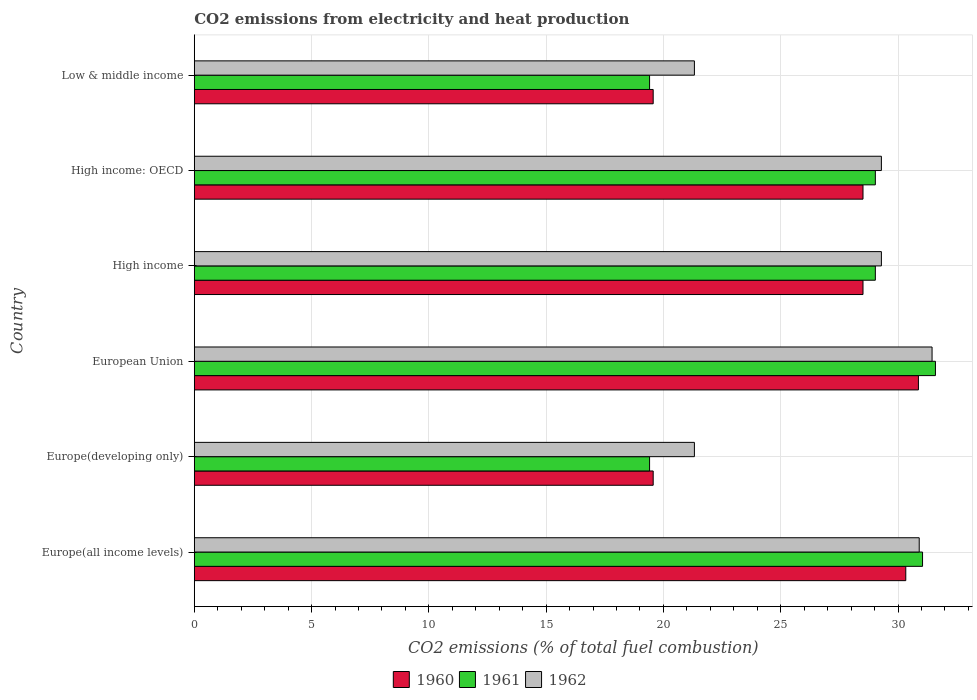How many different coloured bars are there?
Keep it short and to the point. 3. Are the number of bars per tick equal to the number of legend labels?
Make the answer very short. Yes. How many bars are there on the 3rd tick from the top?
Your answer should be compact. 3. How many bars are there on the 1st tick from the bottom?
Your answer should be very brief. 3. What is the label of the 2nd group of bars from the top?
Your answer should be very brief. High income: OECD. What is the amount of CO2 emitted in 1962 in High income?
Make the answer very short. 29.29. Across all countries, what is the maximum amount of CO2 emitted in 1961?
Provide a short and direct response. 31.59. Across all countries, what is the minimum amount of CO2 emitted in 1961?
Offer a very short reply. 19.41. In which country was the amount of CO2 emitted in 1961 minimum?
Your answer should be compact. Europe(developing only). What is the total amount of CO2 emitted in 1960 in the graph?
Provide a succinct answer. 157.34. What is the difference between the amount of CO2 emitted in 1962 in European Union and that in Low & middle income?
Your response must be concise. 10.13. What is the difference between the amount of CO2 emitted in 1960 in High income: OECD and the amount of CO2 emitted in 1961 in Europe(all income levels)?
Your answer should be very brief. -2.54. What is the average amount of CO2 emitted in 1962 per country?
Provide a short and direct response. 27.26. What is the difference between the amount of CO2 emitted in 1962 and amount of CO2 emitted in 1960 in High income: OECD?
Ensure brevity in your answer.  0.78. In how many countries, is the amount of CO2 emitted in 1960 greater than 12 %?
Your answer should be very brief. 6. What is the ratio of the amount of CO2 emitted in 1961 in Europe(developing only) to that in High income?
Offer a terse response. 0.67. Is the amount of CO2 emitted in 1962 in High income less than that in Low & middle income?
Offer a very short reply. No. Is the difference between the amount of CO2 emitted in 1962 in European Union and High income greater than the difference between the amount of CO2 emitted in 1960 in European Union and High income?
Provide a short and direct response. No. What is the difference between the highest and the second highest amount of CO2 emitted in 1960?
Give a very brief answer. 0.54. What is the difference between the highest and the lowest amount of CO2 emitted in 1960?
Offer a very short reply. 11.31. Is the sum of the amount of CO2 emitted in 1962 in Europe(all income levels) and European Union greater than the maximum amount of CO2 emitted in 1960 across all countries?
Provide a succinct answer. Yes. What does the 2nd bar from the top in High income: OECD represents?
Offer a very short reply. 1961. What does the 3rd bar from the bottom in High income: OECD represents?
Your answer should be compact. 1962. Is it the case that in every country, the sum of the amount of CO2 emitted in 1961 and amount of CO2 emitted in 1960 is greater than the amount of CO2 emitted in 1962?
Give a very brief answer. Yes. How many bars are there?
Offer a very short reply. 18. How many countries are there in the graph?
Your response must be concise. 6. What is the difference between two consecutive major ticks on the X-axis?
Make the answer very short. 5. Are the values on the major ticks of X-axis written in scientific E-notation?
Give a very brief answer. No. Does the graph contain grids?
Offer a terse response. Yes. How many legend labels are there?
Your answer should be compact. 3. How are the legend labels stacked?
Your response must be concise. Horizontal. What is the title of the graph?
Give a very brief answer. CO2 emissions from electricity and heat production. What is the label or title of the X-axis?
Your answer should be very brief. CO2 emissions (% of total fuel combustion). What is the label or title of the Y-axis?
Offer a terse response. Country. What is the CO2 emissions (% of total fuel combustion) in 1960 in Europe(all income levels)?
Offer a terse response. 30.33. What is the CO2 emissions (% of total fuel combustion) in 1961 in Europe(all income levels)?
Provide a short and direct response. 31.04. What is the CO2 emissions (% of total fuel combustion) of 1962 in Europe(all income levels)?
Your answer should be very brief. 30.9. What is the CO2 emissions (% of total fuel combustion) in 1960 in Europe(developing only)?
Make the answer very short. 19.56. What is the CO2 emissions (% of total fuel combustion) in 1961 in Europe(developing only)?
Offer a very short reply. 19.41. What is the CO2 emissions (% of total fuel combustion) of 1962 in Europe(developing only)?
Provide a succinct answer. 21.32. What is the CO2 emissions (% of total fuel combustion) in 1960 in European Union?
Give a very brief answer. 30.87. What is the CO2 emissions (% of total fuel combustion) in 1961 in European Union?
Provide a succinct answer. 31.59. What is the CO2 emissions (% of total fuel combustion) in 1962 in European Union?
Your response must be concise. 31.45. What is the CO2 emissions (% of total fuel combustion) in 1960 in High income?
Ensure brevity in your answer.  28.51. What is the CO2 emissions (% of total fuel combustion) of 1961 in High income?
Provide a succinct answer. 29.03. What is the CO2 emissions (% of total fuel combustion) of 1962 in High income?
Your answer should be compact. 29.29. What is the CO2 emissions (% of total fuel combustion) in 1960 in High income: OECD?
Offer a terse response. 28.51. What is the CO2 emissions (% of total fuel combustion) in 1961 in High income: OECD?
Give a very brief answer. 29.03. What is the CO2 emissions (% of total fuel combustion) in 1962 in High income: OECD?
Your answer should be very brief. 29.29. What is the CO2 emissions (% of total fuel combustion) in 1960 in Low & middle income?
Offer a terse response. 19.56. What is the CO2 emissions (% of total fuel combustion) in 1961 in Low & middle income?
Offer a terse response. 19.41. What is the CO2 emissions (% of total fuel combustion) in 1962 in Low & middle income?
Keep it short and to the point. 21.32. Across all countries, what is the maximum CO2 emissions (% of total fuel combustion) in 1960?
Provide a short and direct response. 30.87. Across all countries, what is the maximum CO2 emissions (% of total fuel combustion) of 1961?
Give a very brief answer. 31.59. Across all countries, what is the maximum CO2 emissions (% of total fuel combustion) in 1962?
Provide a succinct answer. 31.45. Across all countries, what is the minimum CO2 emissions (% of total fuel combustion) of 1960?
Ensure brevity in your answer.  19.56. Across all countries, what is the minimum CO2 emissions (% of total fuel combustion) in 1961?
Your answer should be very brief. 19.41. Across all countries, what is the minimum CO2 emissions (% of total fuel combustion) in 1962?
Provide a succinct answer. 21.32. What is the total CO2 emissions (% of total fuel combustion) of 1960 in the graph?
Make the answer very short. 157.34. What is the total CO2 emissions (% of total fuel combustion) of 1961 in the graph?
Offer a terse response. 159.52. What is the total CO2 emissions (% of total fuel combustion) in 1962 in the graph?
Give a very brief answer. 163.57. What is the difference between the CO2 emissions (% of total fuel combustion) of 1960 in Europe(all income levels) and that in Europe(developing only)?
Offer a terse response. 10.77. What is the difference between the CO2 emissions (% of total fuel combustion) in 1961 in Europe(all income levels) and that in Europe(developing only)?
Provide a succinct answer. 11.64. What is the difference between the CO2 emissions (% of total fuel combustion) of 1962 in Europe(all income levels) and that in Europe(developing only)?
Make the answer very short. 9.58. What is the difference between the CO2 emissions (% of total fuel combustion) in 1960 in Europe(all income levels) and that in European Union?
Keep it short and to the point. -0.54. What is the difference between the CO2 emissions (% of total fuel combustion) in 1961 in Europe(all income levels) and that in European Union?
Your response must be concise. -0.55. What is the difference between the CO2 emissions (% of total fuel combustion) of 1962 in Europe(all income levels) and that in European Union?
Offer a terse response. -0.55. What is the difference between the CO2 emissions (% of total fuel combustion) in 1960 in Europe(all income levels) and that in High income?
Ensure brevity in your answer.  1.82. What is the difference between the CO2 emissions (% of total fuel combustion) of 1961 in Europe(all income levels) and that in High income?
Provide a succinct answer. 2.01. What is the difference between the CO2 emissions (% of total fuel combustion) of 1962 in Europe(all income levels) and that in High income?
Give a very brief answer. 1.61. What is the difference between the CO2 emissions (% of total fuel combustion) in 1960 in Europe(all income levels) and that in High income: OECD?
Provide a short and direct response. 1.82. What is the difference between the CO2 emissions (% of total fuel combustion) in 1961 in Europe(all income levels) and that in High income: OECD?
Make the answer very short. 2.01. What is the difference between the CO2 emissions (% of total fuel combustion) of 1962 in Europe(all income levels) and that in High income: OECD?
Offer a terse response. 1.61. What is the difference between the CO2 emissions (% of total fuel combustion) in 1960 in Europe(all income levels) and that in Low & middle income?
Your answer should be very brief. 10.77. What is the difference between the CO2 emissions (% of total fuel combustion) of 1961 in Europe(all income levels) and that in Low & middle income?
Keep it short and to the point. 11.64. What is the difference between the CO2 emissions (% of total fuel combustion) in 1962 in Europe(all income levels) and that in Low & middle income?
Make the answer very short. 9.58. What is the difference between the CO2 emissions (% of total fuel combustion) in 1960 in Europe(developing only) and that in European Union?
Give a very brief answer. -11.31. What is the difference between the CO2 emissions (% of total fuel combustion) in 1961 in Europe(developing only) and that in European Union?
Give a very brief answer. -12.19. What is the difference between the CO2 emissions (% of total fuel combustion) of 1962 in Europe(developing only) and that in European Union?
Your answer should be compact. -10.13. What is the difference between the CO2 emissions (% of total fuel combustion) in 1960 in Europe(developing only) and that in High income?
Keep it short and to the point. -8.94. What is the difference between the CO2 emissions (% of total fuel combustion) of 1961 in Europe(developing only) and that in High income?
Provide a succinct answer. -9.62. What is the difference between the CO2 emissions (% of total fuel combustion) of 1962 in Europe(developing only) and that in High income?
Give a very brief answer. -7.97. What is the difference between the CO2 emissions (% of total fuel combustion) in 1960 in Europe(developing only) and that in High income: OECD?
Your answer should be compact. -8.94. What is the difference between the CO2 emissions (% of total fuel combustion) of 1961 in Europe(developing only) and that in High income: OECD?
Provide a succinct answer. -9.62. What is the difference between the CO2 emissions (% of total fuel combustion) of 1962 in Europe(developing only) and that in High income: OECD?
Keep it short and to the point. -7.97. What is the difference between the CO2 emissions (% of total fuel combustion) in 1960 in Europe(developing only) and that in Low & middle income?
Ensure brevity in your answer.  0. What is the difference between the CO2 emissions (% of total fuel combustion) of 1961 in Europe(developing only) and that in Low & middle income?
Give a very brief answer. 0. What is the difference between the CO2 emissions (% of total fuel combustion) in 1962 in Europe(developing only) and that in Low & middle income?
Provide a succinct answer. 0. What is the difference between the CO2 emissions (% of total fuel combustion) of 1960 in European Union and that in High income?
Keep it short and to the point. 2.36. What is the difference between the CO2 emissions (% of total fuel combustion) in 1961 in European Union and that in High income?
Provide a succinct answer. 2.56. What is the difference between the CO2 emissions (% of total fuel combustion) in 1962 in European Union and that in High income?
Make the answer very short. 2.16. What is the difference between the CO2 emissions (% of total fuel combustion) of 1960 in European Union and that in High income: OECD?
Your answer should be compact. 2.36. What is the difference between the CO2 emissions (% of total fuel combustion) in 1961 in European Union and that in High income: OECD?
Offer a terse response. 2.56. What is the difference between the CO2 emissions (% of total fuel combustion) in 1962 in European Union and that in High income: OECD?
Give a very brief answer. 2.16. What is the difference between the CO2 emissions (% of total fuel combustion) in 1960 in European Union and that in Low & middle income?
Your answer should be compact. 11.31. What is the difference between the CO2 emissions (% of total fuel combustion) in 1961 in European Union and that in Low & middle income?
Give a very brief answer. 12.19. What is the difference between the CO2 emissions (% of total fuel combustion) in 1962 in European Union and that in Low & middle income?
Provide a succinct answer. 10.13. What is the difference between the CO2 emissions (% of total fuel combustion) of 1962 in High income and that in High income: OECD?
Your answer should be compact. 0. What is the difference between the CO2 emissions (% of total fuel combustion) in 1960 in High income and that in Low & middle income?
Provide a short and direct response. 8.94. What is the difference between the CO2 emissions (% of total fuel combustion) of 1961 in High income and that in Low & middle income?
Offer a very short reply. 9.62. What is the difference between the CO2 emissions (% of total fuel combustion) of 1962 in High income and that in Low & middle income?
Provide a short and direct response. 7.97. What is the difference between the CO2 emissions (% of total fuel combustion) in 1960 in High income: OECD and that in Low & middle income?
Your answer should be very brief. 8.94. What is the difference between the CO2 emissions (% of total fuel combustion) in 1961 in High income: OECD and that in Low & middle income?
Your answer should be very brief. 9.62. What is the difference between the CO2 emissions (% of total fuel combustion) of 1962 in High income: OECD and that in Low & middle income?
Provide a short and direct response. 7.97. What is the difference between the CO2 emissions (% of total fuel combustion) in 1960 in Europe(all income levels) and the CO2 emissions (% of total fuel combustion) in 1961 in Europe(developing only)?
Offer a terse response. 10.92. What is the difference between the CO2 emissions (% of total fuel combustion) in 1960 in Europe(all income levels) and the CO2 emissions (% of total fuel combustion) in 1962 in Europe(developing only)?
Offer a very short reply. 9.01. What is the difference between the CO2 emissions (% of total fuel combustion) of 1961 in Europe(all income levels) and the CO2 emissions (% of total fuel combustion) of 1962 in Europe(developing only)?
Your response must be concise. 9.73. What is the difference between the CO2 emissions (% of total fuel combustion) of 1960 in Europe(all income levels) and the CO2 emissions (% of total fuel combustion) of 1961 in European Union?
Your answer should be compact. -1.26. What is the difference between the CO2 emissions (% of total fuel combustion) of 1960 in Europe(all income levels) and the CO2 emissions (% of total fuel combustion) of 1962 in European Union?
Your answer should be very brief. -1.12. What is the difference between the CO2 emissions (% of total fuel combustion) in 1961 in Europe(all income levels) and the CO2 emissions (% of total fuel combustion) in 1962 in European Union?
Provide a short and direct response. -0.41. What is the difference between the CO2 emissions (% of total fuel combustion) of 1960 in Europe(all income levels) and the CO2 emissions (% of total fuel combustion) of 1961 in High income?
Make the answer very short. 1.3. What is the difference between the CO2 emissions (% of total fuel combustion) in 1961 in Europe(all income levels) and the CO2 emissions (% of total fuel combustion) in 1962 in High income?
Give a very brief answer. 1.75. What is the difference between the CO2 emissions (% of total fuel combustion) in 1960 in Europe(all income levels) and the CO2 emissions (% of total fuel combustion) in 1961 in High income: OECD?
Provide a succinct answer. 1.3. What is the difference between the CO2 emissions (% of total fuel combustion) in 1960 in Europe(all income levels) and the CO2 emissions (% of total fuel combustion) in 1962 in High income: OECD?
Your answer should be very brief. 1.04. What is the difference between the CO2 emissions (% of total fuel combustion) of 1961 in Europe(all income levels) and the CO2 emissions (% of total fuel combustion) of 1962 in High income: OECD?
Make the answer very short. 1.75. What is the difference between the CO2 emissions (% of total fuel combustion) in 1960 in Europe(all income levels) and the CO2 emissions (% of total fuel combustion) in 1961 in Low & middle income?
Your answer should be very brief. 10.92. What is the difference between the CO2 emissions (% of total fuel combustion) of 1960 in Europe(all income levels) and the CO2 emissions (% of total fuel combustion) of 1962 in Low & middle income?
Provide a succinct answer. 9.01. What is the difference between the CO2 emissions (% of total fuel combustion) of 1961 in Europe(all income levels) and the CO2 emissions (% of total fuel combustion) of 1962 in Low & middle income?
Your response must be concise. 9.73. What is the difference between the CO2 emissions (% of total fuel combustion) of 1960 in Europe(developing only) and the CO2 emissions (% of total fuel combustion) of 1961 in European Union?
Offer a very short reply. -12.03. What is the difference between the CO2 emissions (% of total fuel combustion) of 1960 in Europe(developing only) and the CO2 emissions (% of total fuel combustion) of 1962 in European Union?
Offer a very short reply. -11.89. What is the difference between the CO2 emissions (% of total fuel combustion) of 1961 in Europe(developing only) and the CO2 emissions (% of total fuel combustion) of 1962 in European Union?
Your answer should be very brief. -12.04. What is the difference between the CO2 emissions (% of total fuel combustion) of 1960 in Europe(developing only) and the CO2 emissions (% of total fuel combustion) of 1961 in High income?
Make the answer very short. -9.47. What is the difference between the CO2 emissions (% of total fuel combustion) of 1960 in Europe(developing only) and the CO2 emissions (% of total fuel combustion) of 1962 in High income?
Your answer should be compact. -9.73. What is the difference between the CO2 emissions (% of total fuel combustion) of 1961 in Europe(developing only) and the CO2 emissions (% of total fuel combustion) of 1962 in High income?
Your answer should be very brief. -9.88. What is the difference between the CO2 emissions (% of total fuel combustion) of 1960 in Europe(developing only) and the CO2 emissions (% of total fuel combustion) of 1961 in High income: OECD?
Give a very brief answer. -9.47. What is the difference between the CO2 emissions (% of total fuel combustion) in 1960 in Europe(developing only) and the CO2 emissions (% of total fuel combustion) in 1962 in High income: OECD?
Your answer should be compact. -9.73. What is the difference between the CO2 emissions (% of total fuel combustion) of 1961 in Europe(developing only) and the CO2 emissions (% of total fuel combustion) of 1962 in High income: OECD?
Your answer should be compact. -9.88. What is the difference between the CO2 emissions (% of total fuel combustion) of 1960 in Europe(developing only) and the CO2 emissions (% of total fuel combustion) of 1961 in Low & middle income?
Your answer should be very brief. 0.15. What is the difference between the CO2 emissions (% of total fuel combustion) of 1960 in Europe(developing only) and the CO2 emissions (% of total fuel combustion) of 1962 in Low & middle income?
Provide a short and direct response. -1.76. What is the difference between the CO2 emissions (% of total fuel combustion) in 1961 in Europe(developing only) and the CO2 emissions (% of total fuel combustion) in 1962 in Low & middle income?
Provide a short and direct response. -1.91. What is the difference between the CO2 emissions (% of total fuel combustion) in 1960 in European Union and the CO2 emissions (% of total fuel combustion) in 1961 in High income?
Provide a succinct answer. 1.84. What is the difference between the CO2 emissions (% of total fuel combustion) in 1960 in European Union and the CO2 emissions (% of total fuel combustion) in 1962 in High income?
Make the answer very short. 1.58. What is the difference between the CO2 emissions (% of total fuel combustion) of 1961 in European Union and the CO2 emissions (% of total fuel combustion) of 1962 in High income?
Ensure brevity in your answer.  2.3. What is the difference between the CO2 emissions (% of total fuel combustion) in 1960 in European Union and the CO2 emissions (% of total fuel combustion) in 1961 in High income: OECD?
Keep it short and to the point. 1.84. What is the difference between the CO2 emissions (% of total fuel combustion) of 1960 in European Union and the CO2 emissions (% of total fuel combustion) of 1962 in High income: OECD?
Ensure brevity in your answer.  1.58. What is the difference between the CO2 emissions (% of total fuel combustion) of 1961 in European Union and the CO2 emissions (% of total fuel combustion) of 1962 in High income: OECD?
Offer a very short reply. 2.3. What is the difference between the CO2 emissions (% of total fuel combustion) of 1960 in European Union and the CO2 emissions (% of total fuel combustion) of 1961 in Low & middle income?
Provide a succinct answer. 11.46. What is the difference between the CO2 emissions (% of total fuel combustion) of 1960 in European Union and the CO2 emissions (% of total fuel combustion) of 1962 in Low & middle income?
Provide a short and direct response. 9.55. What is the difference between the CO2 emissions (% of total fuel combustion) in 1961 in European Union and the CO2 emissions (% of total fuel combustion) in 1962 in Low & middle income?
Ensure brevity in your answer.  10.27. What is the difference between the CO2 emissions (% of total fuel combustion) in 1960 in High income and the CO2 emissions (% of total fuel combustion) in 1961 in High income: OECD?
Offer a terse response. -0.53. What is the difference between the CO2 emissions (% of total fuel combustion) of 1960 in High income and the CO2 emissions (% of total fuel combustion) of 1962 in High income: OECD?
Ensure brevity in your answer.  -0.78. What is the difference between the CO2 emissions (% of total fuel combustion) of 1961 in High income and the CO2 emissions (% of total fuel combustion) of 1962 in High income: OECD?
Give a very brief answer. -0.26. What is the difference between the CO2 emissions (% of total fuel combustion) of 1960 in High income and the CO2 emissions (% of total fuel combustion) of 1961 in Low & middle income?
Provide a succinct answer. 9.1. What is the difference between the CO2 emissions (% of total fuel combustion) in 1960 in High income and the CO2 emissions (% of total fuel combustion) in 1962 in Low & middle income?
Your answer should be very brief. 7.19. What is the difference between the CO2 emissions (% of total fuel combustion) of 1961 in High income and the CO2 emissions (% of total fuel combustion) of 1962 in Low & middle income?
Make the answer very short. 7.71. What is the difference between the CO2 emissions (% of total fuel combustion) in 1960 in High income: OECD and the CO2 emissions (% of total fuel combustion) in 1961 in Low & middle income?
Keep it short and to the point. 9.1. What is the difference between the CO2 emissions (% of total fuel combustion) of 1960 in High income: OECD and the CO2 emissions (% of total fuel combustion) of 1962 in Low & middle income?
Keep it short and to the point. 7.19. What is the difference between the CO2 emissions (% of total fuel combustion) in 1961 in High income: OECD and the CO2 emissions (% of total fuel combustion) in 1962 in Low & middle income?
Provide a short and direct response. 7.71. What is the average CO2 emissions (% of total fuel combustion) in 1960 per country?
Keep it short and to the point. 26.22. What is the average CO2 emissions (% of total fuel combustion) in 1961 per country?
Offer a terse response. 26.59. What is the average CO2 emissions (% of total fuel combustion) of 1962 per country?
Your response must be concise. 27.26. What is the difference between the CO2 emissions (% of total fuel combustion) of 1960 and CO2 emissions (% of total fuel combustion) of 1961 in Europe(all income levels)?
Your answer should be compact. -0.71. What is the difference between the CO2 emissions (% of total fuel combustion) in 1960 and CO2 emissions (% of total fuel combustion) in 1962 in Europe(all income levels)?
Ensure brevity in your answer.  -0.57. What is the difference between the CO2 emissions (% of total fuel combustion) of 1961 and CO2 emissions (% of total fuel combustion) of 1962 in Europe(all income levels)?
Ensure brevity in your answer.  0.14. What is the difference between the CO2 emissions (% of total fuel combustion) in 1960 and CO2 emissions (% of total fuel combustion) in 1961 in Europe(developing only)?
Your answer should be very brief. 0.15. What is the difference between the CO2 emissions (% of total fuel combustion) of 1960 and CO2 emissions (% of total fuel combustion) of 1962 in Europe(developing only)?
Offer a very short reply. -1.76. What is the difference between the CO2 emissions (% of total fuel combustion) of 1961 and CO2 emissions (% of total fuel combustion) of 1962 in Europe(developing only)?
Ensure brevity in your answer.  -1.91. What is the difference between the CO2 emissions (% of total fuel combustion) of 1960 and CO2 emissions (% of total fuel combustion) of 1961 in European Union?
Your response must be concise. -0.73. What is the difference between the CO2 emissions (% of total fuel combustion) in 1960 and CO2 emissions (% of total fuel combustion) in 1962 in European Union?
Provide a succinct answer. -0.58. What is the difference between the CO2 emissions (% of total fuel combustion) of 1961 and CO2 emissions (% of total fuel combustion) of 1962 in European Union?
Ensure brevity in your answer.  0.14. What is the difference between the CO2 emissions (% of total fuel combustion) in 1960 and CO2 emissions (% of total fuel combustion) in 1961 in High income?
Make the answer very short. -0.53. What is the difference between the CO2 emissions (% of total fuel combustion) of 1960 and CO2 emissions (% of total fuel combustion) of 1962 in High income?
Provide a short and direct response. -0.78. What is the difference between the CO2 emissions (% of total fuel combustion) in 1961 and CO2 emissions (% of total fuel combustion) in 1962 in High income?
Provide a succinct answer. -0.26. What is the difference between the CO2 emissions (% of total fuel combustion) of 1960 and CO2 emissions (% of total fuel combustion) of 1961 in High income: OECD?
Provide a short and direct response. -0.53. What is the difference between the CO2 emissions (% of total fuel combustion) of 1960 and CO2 emissions (% of total fuel combustion) of 1962 in High income: OECD?
Your answer should be very brief. -0.78. What is the difference between the CO2 emissions (% of total fuel combustion) in 1961 and CO2 emissions (% of total fuel combustion) in 1962 in High income: OECD?
Make the answer very short. -0.26. What is the difference between the CO2 emissions (% of total fuel combustion) in 1960 and CO2 emissions (% of total fuel combustion) in 1961 in Low & middle income?
Make the answer very short. 0.15. What is the difference between the CO2 emissions (% of total fuel combustion) of 1960 and CO2 emissions (% of total fuel combustion) of 1962 in Low & middle income?
Your response must be concise. -1.76. What is the difference between the CO2 emissions (% of total fuel combustion) in 1961 and CO2 emissions (% of total fuel combustion) in 1962 in Low & middle income?
Give a very brief answer. -1.91. What is the ratio of the CO2 emissions (% of total fuel combustion) of 1960 in Europe(all income levels) to that in Europe(developing only)?
Offer a terse response. 1.55. What is the ratio of the CO2 emissions (% of total fuel combustion) of 1961 in Europe(all income levels) to that in Europe(developing only)?
Offer a terse response. 1.6. What is the ratio of the CO2 emissions (% of total fuel combustion) of 1962 in Europe(all income levels) to that in Europe(developing only)?
Make the answer very short. 1.45. What is the ratio of the CO2 emissions (% of total fuel combustion) of 1960 in Europe(all income levels) to that in European Union?
Offer a terse response. 0.98. What is the ratio of the CO2 emissions (% of total fuel combustion) of 1961 in Europe(all income levels) to that in European Union?
Ensure brevity in your answer.  0.98. What is the ratio of the CO2 emissions (% of total fuel combustion) of 1962 in Europe(all income levels) to that in European Union?
Offer a very short reply. 0.98. What is the ratio of the CO2 emissions (% of total fuel combustion) in 1960 in Europe(all income levels) to that in High income?
Make the answer very short. 1.06. What is the ratio of the CO2 emissions (% of total fuel combustion) of 1961 in Europe(all income levels) to that in High income?
Provide a succinct answer. 1.07. What is the ratio of the CO2 emissions (% of total fuel combustion) in 1962 in Europe(all income levels) to that in High income?
Make the answer very short. 1.06. What is the ratio of the CO2 emissions (% of total fuel combustion) of 1960 in Europe(all income levels) to that in High income: OECD?
Provide a short and direct response. 1.06. What is the ratio of the CO2 emissions (% of total fuel combustion) of 1961 in Europe(all income levels) to that in High income: OECD?
Your response must be concise. 1.07. What is the ratio of the CO2 emissions (% of total fuel combustion) of 1962 in Europe(all income levels) to that in High income: OECD?
Your response must be concise. 1.06. What is the ratio of the CO2 emissions (% of total fuel combustion) of 1960 in Europe(all income levels) to that in Low & middle income?
Your answer should be compact. 1.55. What is the ratio of the CO2 emissions (% of total fuel combustion) of 1961 in Europe(all income levels) to that in Low & middle income?
Provide a succinct answer. 1.6. What is the ratio of the CO2 emissions (% of total fuel combustion) in 1962 in Europe(all income levels) to that in Low & middle income?
Offer a terse response. 1.45. What is the ratio of the CO2 emissions (% of total fuel combustion) in 1960 in Europe(developing only) to that in European Union?
Your answer should be compact. 0.63. What is the ratio of the CO2 emissions (% of total fuel combustion) in 1961 in Europe(developing only) to that in European Union?
Ensure brevity in your answer.  0.61. What is the ratio of the CO2 emissions (% of total fuel combustion) of 1962 in Europe(developing only) to that in European Union?
Offer a very short reply. 0.68. What is the ratio of the CO2 emissions (% of total fuel combustion) of 1960 in Europe(developing only) to that in High income?
Provide a short and direct response. 0.69. What is the ratio of the CO2 emissions (% of total fuel combustion) in 1961 in Europe(developing only) to that in High income?
Make the answer very short. 0.67. What is the ratio of the CO2 emissions (% of total fuel combustion) in 1962 in Europe(developing only) to that in High income?
Offer a very short reply. 0.73. What is the ratio of the CO2 emissions (% of total fuel combustion) of 1960 in Europe(developing only) to that in High income: OECD?
Offer a very short reply. 0.69. What is the ratio of the CO2 emissions (% of total fuel combustion) in 1961 in Europe(developing only) to that in High income: OECD?
Give a very brief answer. 0.67. What is the ratio of the CO2 emissions (% of total fuel combustion) of 1962 in Europe(developing only) to that in High income: OECD?
Give a very brief answer. 0.73. What is the ratio of the CO2 emissions (% of total fuel combustion) of 1960 in Europe(developing only) to that in Low & middle income?
Provide a short and direct response. 1. What is the ratio of the CO2 emissions (% of total fuel combustion) in 1961 in Europe(developing only) to that in Low & middle income?
Offer a very short reply. 1. What is the ratio of the CO2 emissions (% of total fuel combustion) in 1960 in European Union to that in High income?
Your response must be concise. 1.08. What is the ratio of the CO2 emissions (% of total fuel combustion) of 1961 in European Union to that in High income?
Make the answer very short. 1.09. What is the ratio of the CO2 emissions (% of total fuel combustion) of 1962 in European Union to that in High income?
Provide a succinct answer. 1.07. What is the ratio of the CO2 emissions (% of total fuel combustion) in 1960 in European Union to that in High income: OECD?
Your response must be concise. 1.08. What is the ratio of the CO2 emissions (% of total fuel combustion) in 1961 in European Union to that in High income: OECD?
Provide a short and direct response. 1.09. What is the ratio of the CO2 emissions (% of total fuel combustion) of 1962 in European Union to that in High income: OECD?
Offer a terse response. 1.07. What is the ratio of the CO2 emissions (% of total fuel combustion) in 1960 in European Union to that in Low & middle income?
Keep it short and to the point. 1.58. What is the ratio of the CO2 emissions (% of total fuel combustion) in 1961 in European Union to that in Low & middle income?
Your answer should be very brief. 1.63. What is the ratio of the CO2 emissions (% of total fuel combustion) in 1962 in European Union to that in Low & middle income?
Keep it short and to the point. 1.48. What is the ratio of the CO2 emissions (% of total fuel combustion) of 1961 in High income to that in High income: OECD?
Provide a short and direct response. 1. What is the ratio of the CO2 emissions (% of total fuel combustion) of 1960 in High income to that in Low & middle income?
Make the answer very short. 1.46. What is the ratio of the CO2 emissions (% of total fuel combustion) in 1961 in High income to that in Low & middle income?
Your answer should be compact. 1.5. What is the ratio of the CO2 emissions (% of total fuel combustion) of 1962 in High income to that in Low & middle income?
Keep it short and to the point. 1.37. What is the ratio of the CO2 emissions (% of total fuel combustion) in 1960 in High income: OECD to that in Low & middle income?
Your answer should be very brief. 1.46. What is the ratio of the CO2 emissions (% of total fuel combustion) in 1961 in High income: OECD to that in Low & middle income?
Provide a succinct answer. 1.5. What is the ratio of the CO2 emissions (% of total fuel combustion) in 1962 in High income: OECD to that in Low & middle income?
Your response must be concise. 1.37. What is the difference between the highest and the second highest CO2 emissions (% of total fuel combustion) of 1960?
Offer a terse response. 0.54. What is the difference between the highest and the second highest CO2 emissions (% of total fuel combustion) in 1961?
Keep it short and to the point. 0.55. What is the difference between the highest and the second highest CO2 emissions (% of total fuel combustion) of 1962?
Your answer should be compact. 0.55. What is the difference between the highest and the lowest CO2 emissions (% of total fuel combustion) of 1960?
Offer a terse response. 11.31. What is the difference between the highest and the lowest CO2 emissions (% of total fuel combustion) in 1961?
Your answer should be compact. 12.19. What is the difference between the highest and the lowest CO2 emissions (% of total fuel combustion) of 1962?
Provide a succinct answer. 10.13. 